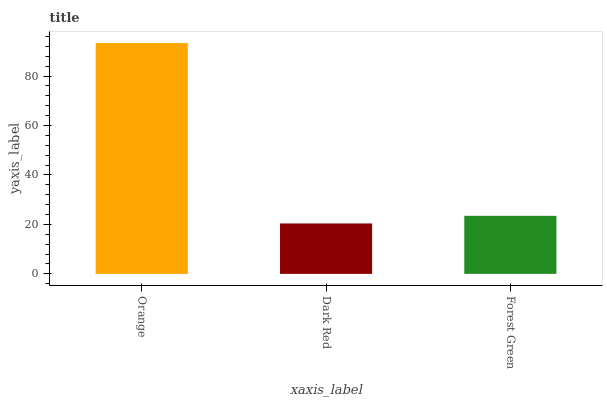Is Dark Red the minimum?
Answer yes or no. Yes. Is Orange the maximum?
Answer yes or no. Yes. Is Forest Green the minimum?
Answer yes or no. No. Is Forest Green the maximum?
Answer yes or no. No. Is Forest Green greater than Dark Red?
Answer yes or no. Yes. Is Dark Red less than Forest Green?
Answer yes or no. Yes. Is Dark Red greater than Forest Green?
Answer yes or no. No. Is Forest Green less than Dark Red?
Answer yes or no. No. Is Forest Green the high median?
Answer yes or no. Yes. Is Forest Green the low median?
Answer yes or no. Yes. Is Dark Red the high median?
Answer yes or no. No. Is Orange the low median?
Answer yes or no. No. 